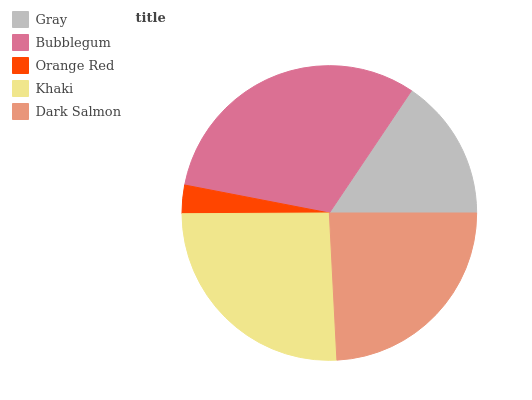Is Orange Red the minimum?
Answer yes or no. Yes. Is Bubblegum the maximum?
Answer yes or no. Yes. Is Bubblegum the minimum?
Answer yes or no. No. Is Orange Red the maximum?
Answer yes or no. No. Is Bubblegum greater than Orange Red?
Answer yes or no. Yes. Is Orange Red less than Bubblegum?
Answer yes or no. Yes. Is Orange Red greater than Bubblegum?
Answer yes or no. No. Is Bubblegum less than Orange Red?
Answer yes or no. No. Is Dark Salmon the high median?
Answer yes or no. Yes. Is Dark Salmon the low median?
Answer yes or no. Yes. Is Orange Red the high median?
Answer yes or no. No. Is Orange Red the low median?
Answer yes or no. No. 